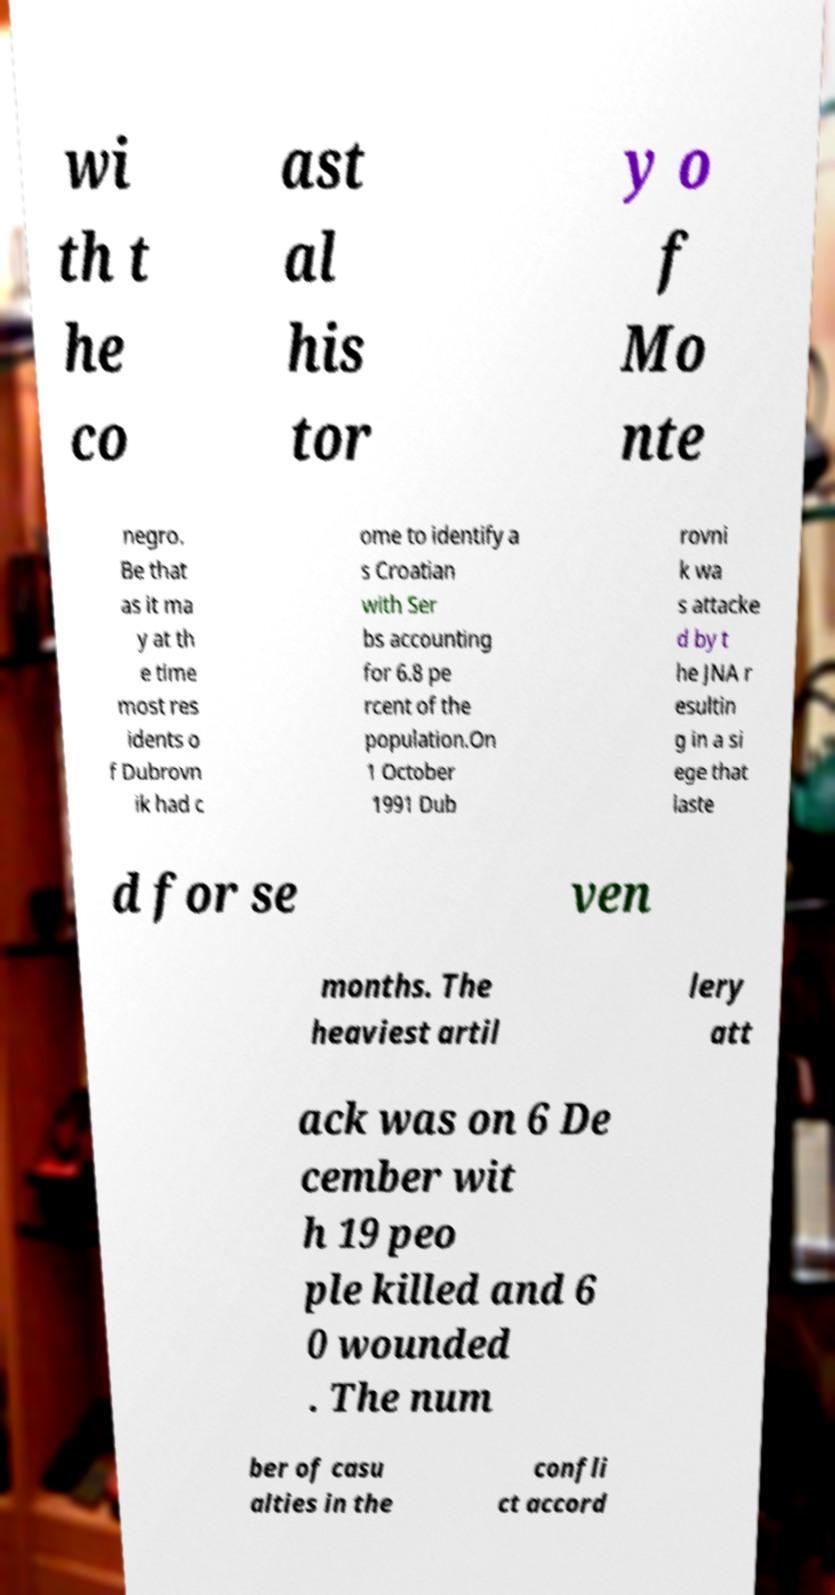I need the written content from this picture converted into text. Can you do that? wi th t he co ast al his tor y o f Mo nte negro. Be that as it ma y at th e time most res idents o f Dubrovn ik had c ome to identify a s Croatian with Ser bs accounting for 6.8 pe rcent of the population.On 1 October 1991 Dub rovni k wa s attacke d by t he JNA r esultin g in a si ege that laste d for se ven months. The heaviest artil lery att ack was on 6 De cember wit h 19 peo ple killed and 6 0 wounded . The num ber of casu alties in the confli ct accord 